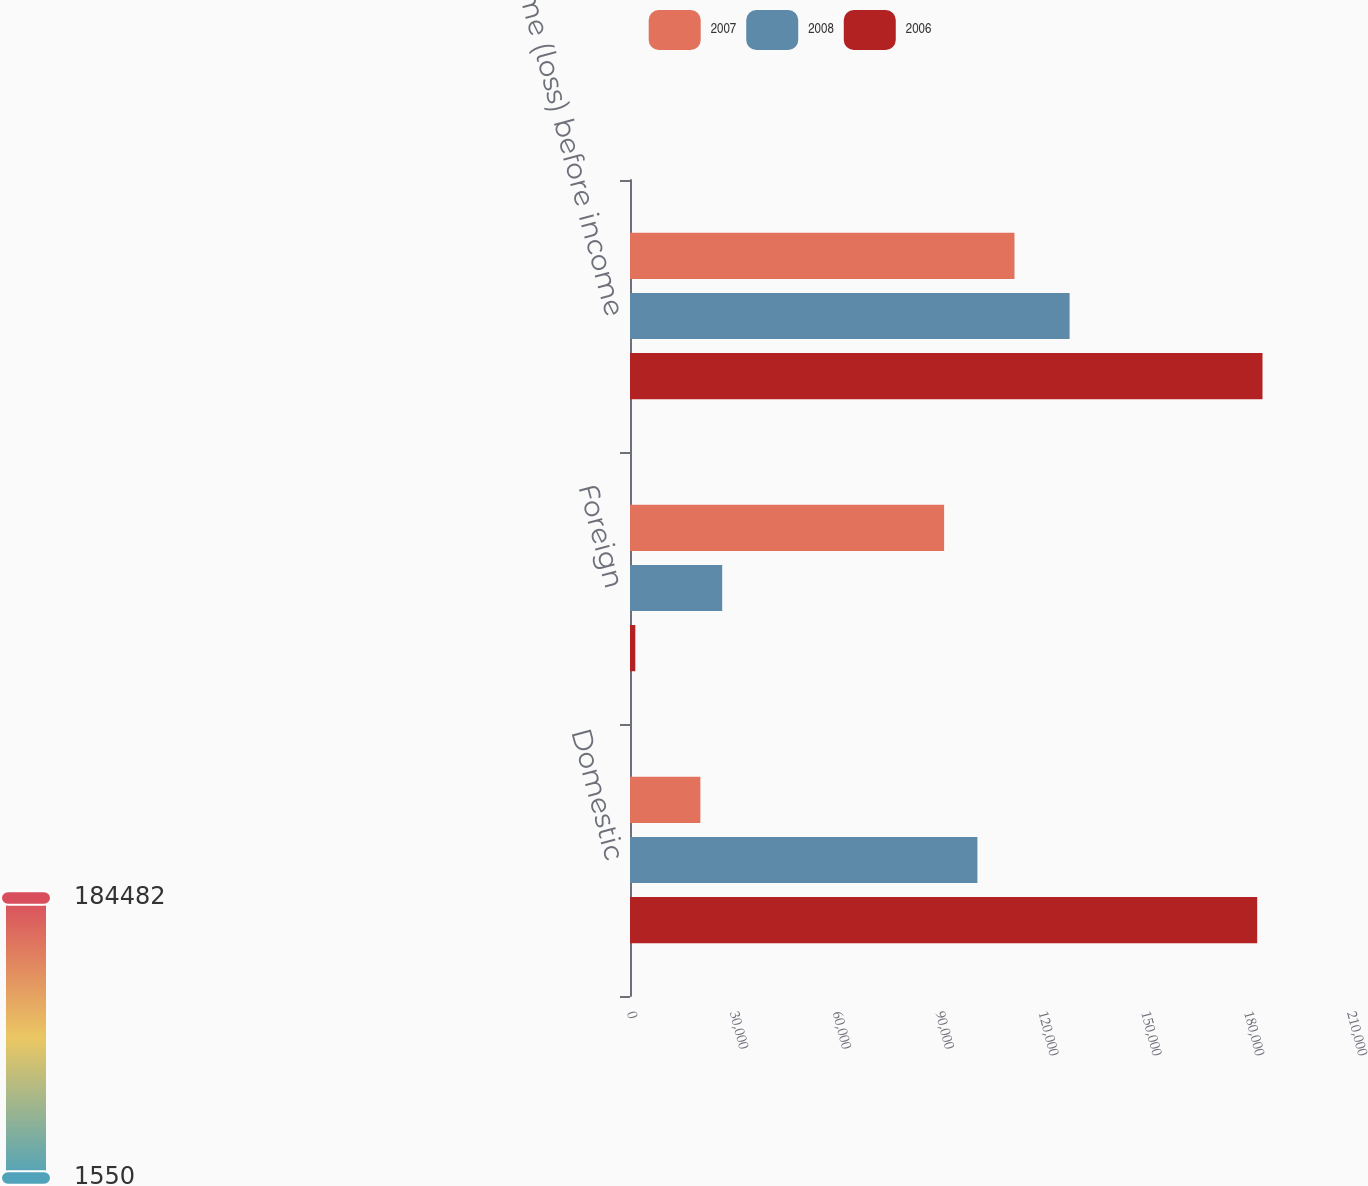Convert chart. <chart><loc_0><loc_0><loc_500><loc_500><stacked_bar_chart><ecel><fcel>Domestic<fcel>Foreign<fcel>Income (loss) before income<nl><fcel>2007<fcel>20528<fcel>91615<fcel>112143<nl><fcel>2008<fcel>101328<fcel>26887<fcel>128215<nl><fcel>2006<fcel>182932<fcel>1550<fcel>184482<nl></chart> 